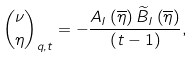<formula> <loc_0><loc_0><loc_500><loc_500>\binom { \nu } { \eta } _ { q , t } = - \frac { A _ { I } \left ( \overline { \eta } \right ) \widetilde { B } _ { I } \left ( \overline { \eta } \right ) } { \left ( t - 1 \right ) } ,</formula> 